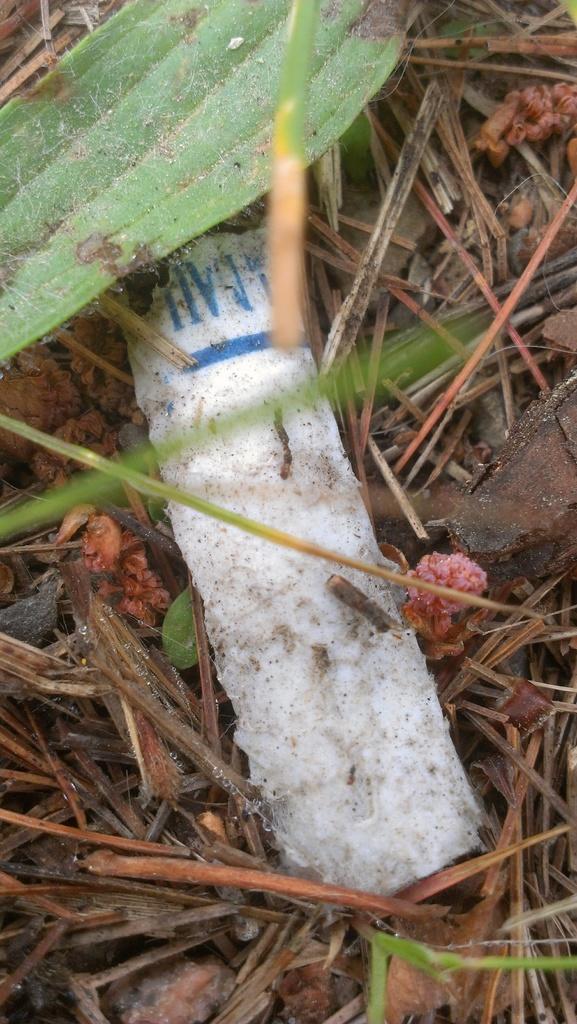Describe this image in one or two sentences. In the image we can see grass and white color object. 